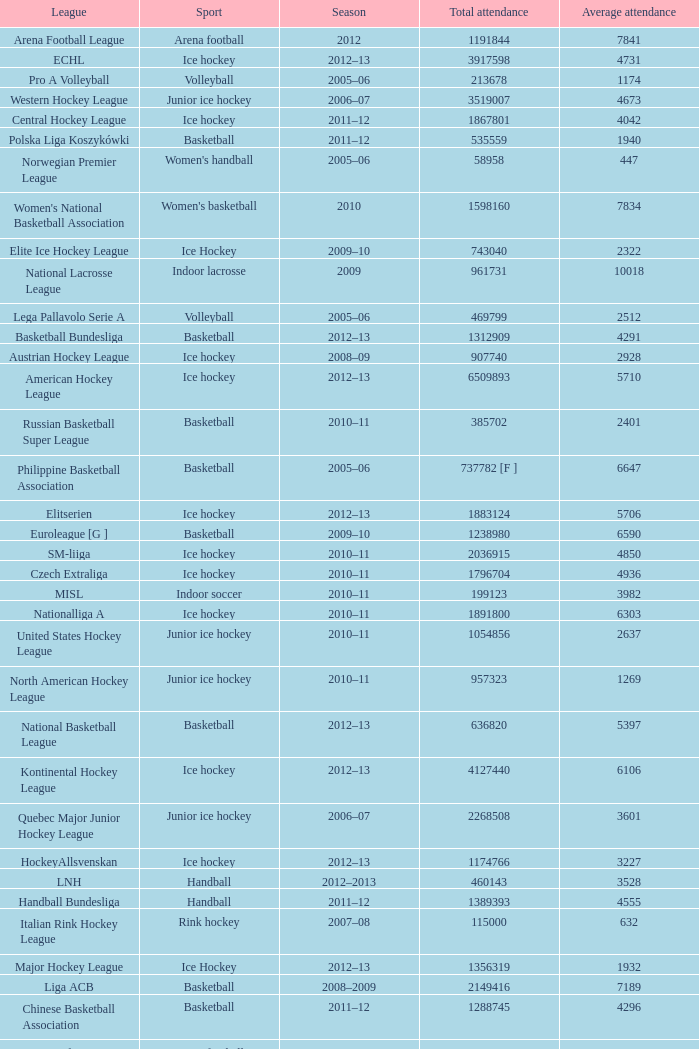What's the average attendance of the league with a total attendance of 2268508? 3601.0. 